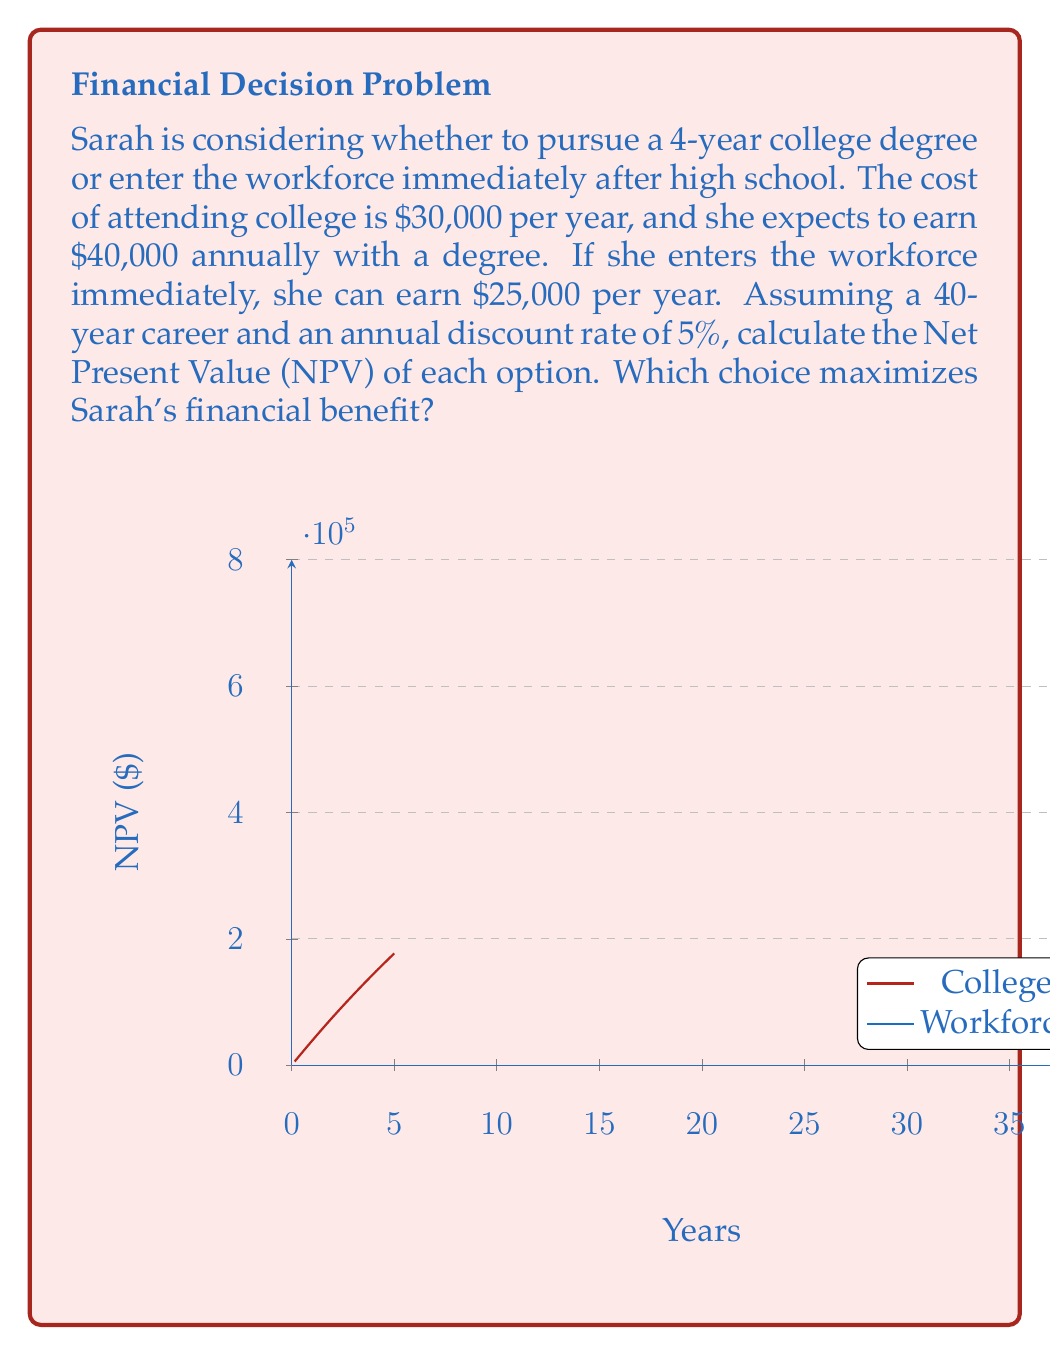Can you answer this question? Let's approach this step-by-step:

1) First, we need to calculate the NPV for each option. The NPV formula is:

   $$NPV = \sum_{t=0}^{n} \frac{CF_t}{(1+r)^t}$$

   Where $CF_t$ is the cash flow at time $t$, $r$ is the discount rate, and $n$ is the number of periods.

2) For the college option:
   - Cost: $-30,000 per year for 4 years
   - Benefit: $40,000 per year for 36 years (40-year career minus 4 years of college)
   
   $$NPV_{college} = \sum_{t=0}^{3} \frac{-30,000}{(1.05)^t} + \sum_{t=4}^{39} \frac{40,000}{(1.05)^t}$$

3) For the workforce option:
   - Benefit: $25,000 per year for 40 years
   
   $$NPV_{workforce} = \sum_{t=0}^{39} \frac{25,000}{(1.05)^t}$$

4) Using a financial calculator or spreadsheet to solve these equations:

   $NPV_{college} \approx $614,812.84$
   $NPV_{workforce} \approx $466,228.86$

5) The difference in NPV is:

   $614,812.84 - 466,228.86 = $148,583.98$

Therefore, pursuing a college degree provides a higher financial benefit of approximately $148,584 over the course of Sarah's career.
Answer: College degree: NPV = $614,812.84; Workforce: NPV = $466,228.86. College maximizes financial benefit by $148,583.98. 